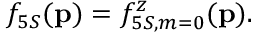Convert formula to latex. <formula><loc_0><loc_0><loc_500><loc_500>f _ { 5 S } ( { p } ) = f _ { 5 S , m = 0 } ^ { z } ( { p } ) .</formula> 